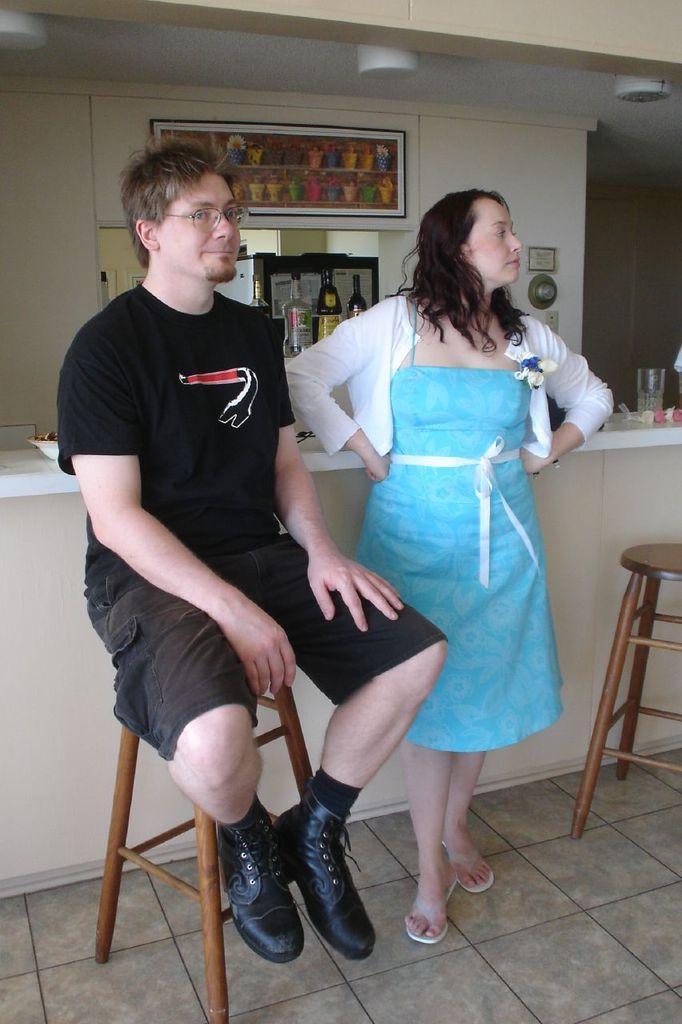Please provide a concise description of this image. In this image there are two persons. One person is sitting on the table. At the back side I can see bottles and a glass. 